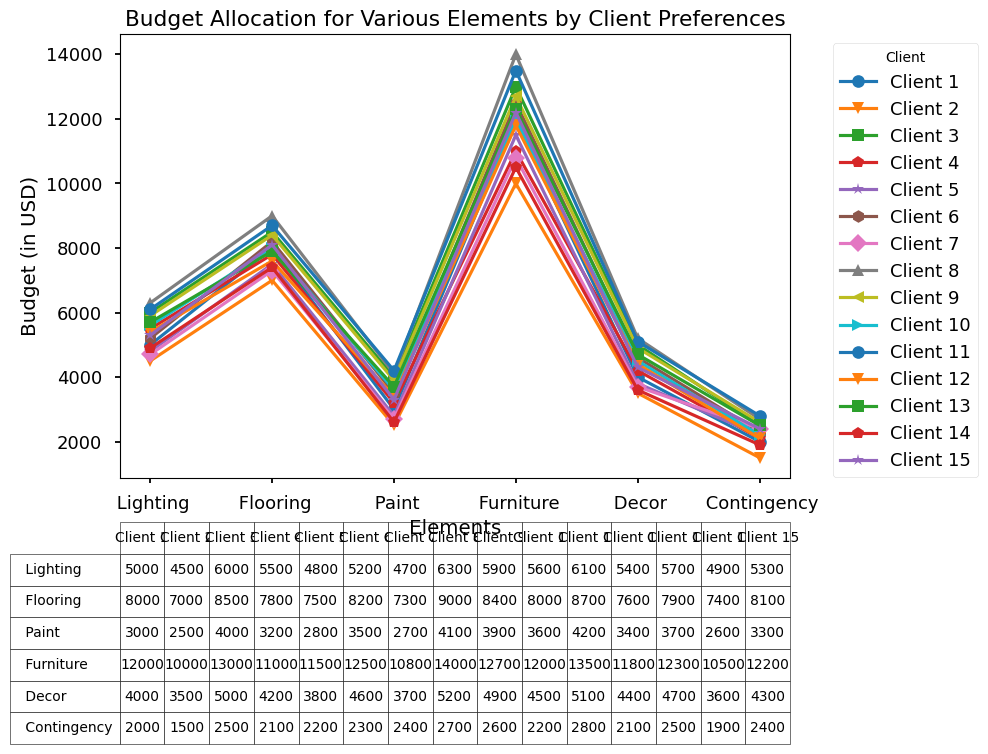What is the total budget allocated by Client 1? To calculate the total budget allocated by Client 1, sum the values for each element: Lighting (5000) + Flooring (8000) + Paint (3000) + Furniture (12000) + Decor (4000) + Contingency (2000) = 34000.
Answer: 34000 Which client has the highest budget for Lighting? By checking the Lighting values for all clients, Client 8 has the highest value with 6300.
Answer: Client 8 Which client allocated the least budget for Furniture? By checking the Furniture values for all clients, Client 14 has the lowest value with 10500.
Answer: Client 14 What is the average budget for Flooring across all clients? Sum up all Flooring values and divide by the number of clients: (8000 + 7000 + 8500 + 7800 + 7500 + 8200 + 7300 + 9000 + 8400 + 8000 + 8700 + 7600 + 7900 + 7400 + 8100) / 15 = 7973.33.
Answer: 7973.33 Which category has the highest average budget across all clients? Calculate the average for each category: Lighting (5266.67), Flooring (7973.33), Paint (3340.00), Furniture (11926.67), Decor (4293.33), Contingency (2260.00). Furniture has the highest average.
Answer: Furniture Which client has a higher budget for Paint, Client 3 or Client 12? Compare the Paint budget: Client 3 (4000) vs. Client 12 (3400). Client 3 has a higher budget for Paint.
Answer: Client 3 What is the difference in the budget for Decor between Client 7 and Client 9? Subtract Client 7's budget for Decor from Client 9's: 4900 - 3700 = 1200.
Answer: 1200 Which element shows the most budget variability among clients? By observing the range (max-min) for each element: Lighting (1800), Flooring (2000), Paint (1700), Furniture (3500), Decor (1600), Contingency (1300). Furniture shows the most variability with a range of 3500.
Answer: Furniture What is the total budget allocated by Client 5 for Flooring and Paint combined? Add Flooring and Paint values for Client 5: 7500 (Flooring) + 2800 (Paint) = 10300.
Answer: 10300 Which client allocated more to Lighting than Flooring? Compare Lighting and Flooring values for each client. Only Client 8 allocated more to Lighting (6300) than Flooring (6000).
Answer: Client 8 